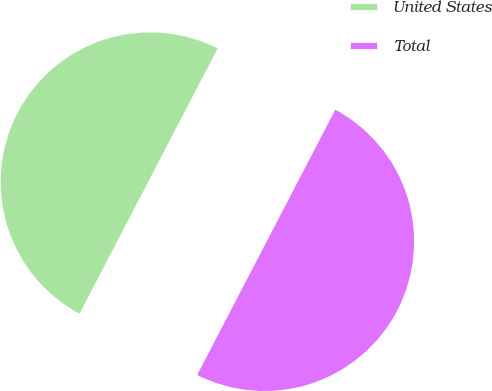Convert chart to OTSL. <chart><loc_0><loc_0><loc_500><loc_500><pie_chart><fcel>United States<fcel>Total<nl><fcel>50.0%<fcel>50.0%<nl></chart> 